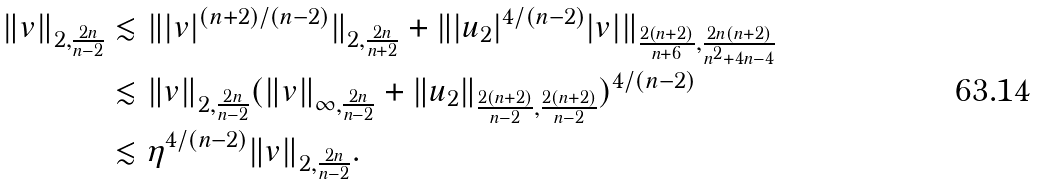Convert formula to latex. <formula><loc_0><loc_0><loc_500><loc_500>\| v \| _ { 2 , \frac { 2 n } { n - 2 } } & \lesssim \| | v | ^ { ( n + 2 ) / ( n - 2 ) } \| _ { 2 , \frac { 2 n } { n + 2 } } + \| | u _ { 2 } | ^ { 4 / ( n - 2 ) } | v | \| _ { \frac { 2 ( n + 2 ) } { n + 6 } , \frac { 2 n ( n + 2 ) } { n ^ { 2 } + 4 n - 4 } } \\ & \lesssim \| v \| _ { 2 , \frac { 2 n } { n - 2 } } ( \| v \| _ { \infty , \frac { 2 n } { n - 2 } } + \| u _ { 2 } \| _ { \frac { 2 ( n + 2 ) } { n - 2 } , \frac { 2 ( n + 2 ) } { n - 2 } } ) ^ { 4 / ( n - 2 ) } \\ & \lesssim \eta ^ { 4 / ( n - 2 ) } \| v \| _ { 2 , \frac { 2 n } { n - 2 } } .</formula> 